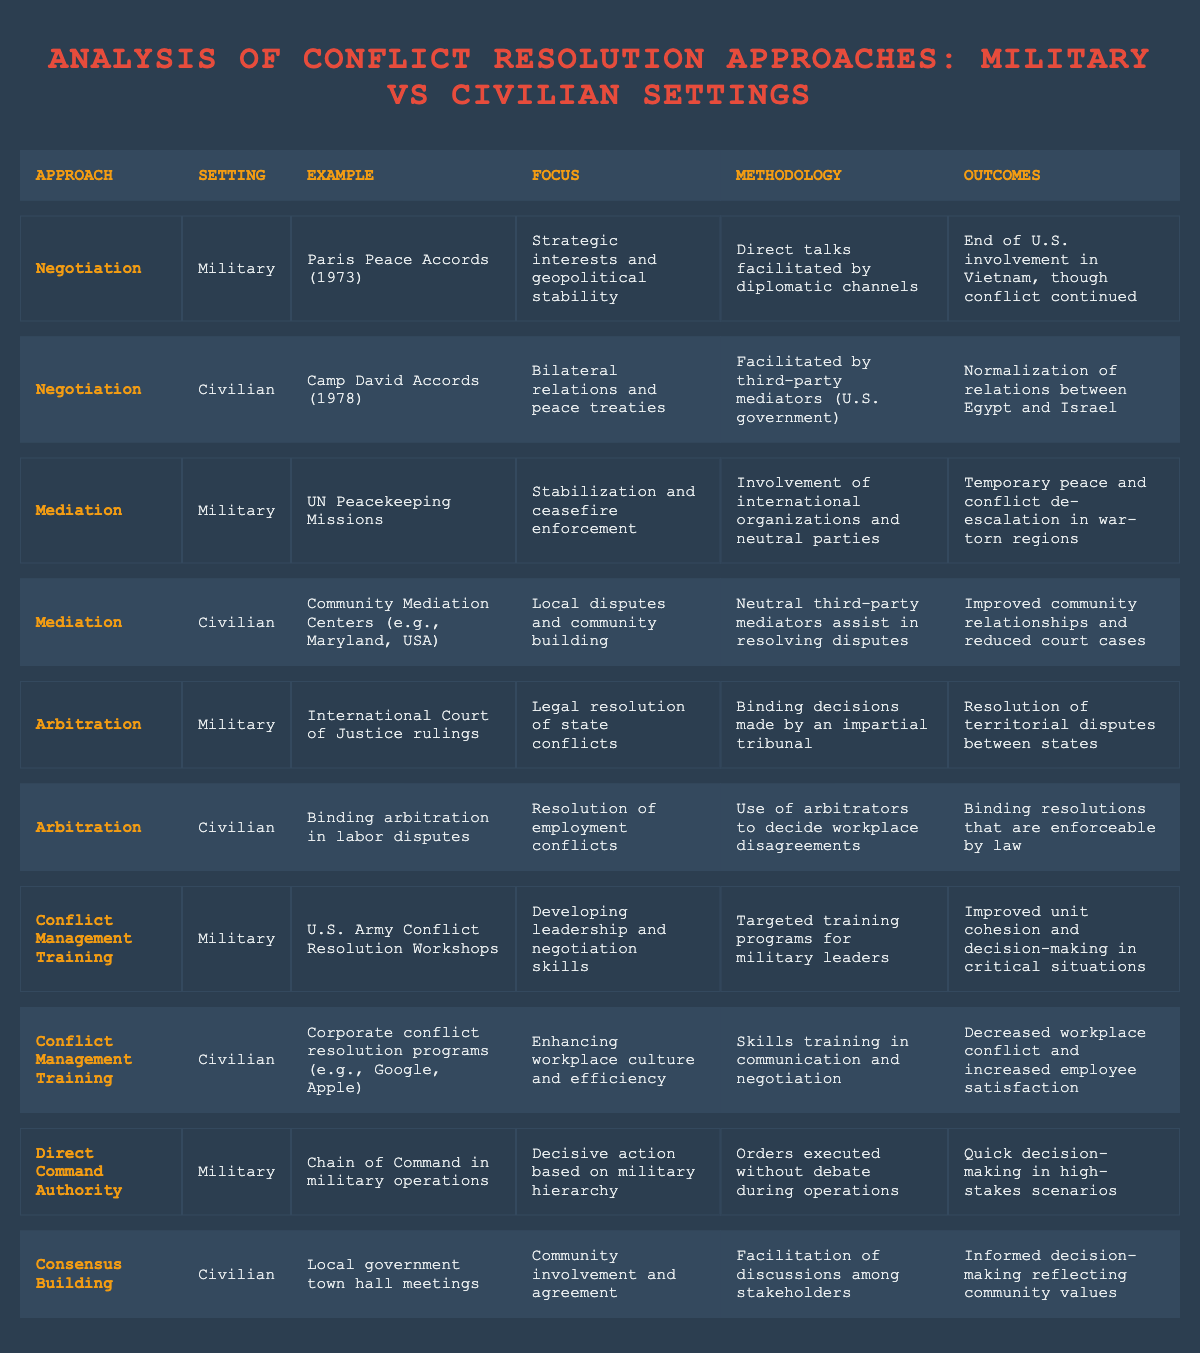What are the two conflict resolution approaches used in military settings? The table lists the conflict resolution approaches used in military settings. They are Negotiation and Mediation.
Answer: Negotiation, Mediation Which approach utilizes third-party mediators in civilian settings? The table indicates that the Negotiation approach in civilian settings uses third-party mediators, specifically in the Camp David Accords example.
Answer: Negotiation How many military approaches focus on stabilization and ceasefire enforcement? The table provides one specific approach, which is Mediation, noted for focusing on stabilization and ceasefire enforcement through UN Peacekeeping Missions.
Answer: 1 What was the outcome of the Paris Peace Accords? From the table, the outcome of the Paris Peace Accords is the end of U.S. involvement in Vietnam, though conflict continued.
Answer: End of U.S. involvement in Vietnam, conflict continued What is the difference in focus between military and civilian approaches to negotiation? The military approach focuses on strategic interests and geopolitical stability, while the civilian approach emphasizes bilateral relations and peace treaties.
Answer: Strategic interests (military) vs. bilateral relations (civilian) Which two approaches are associated with binding decisions? The table shows that Arbitration is associated with binding decisions in both military (International Court of Justice rulings) and civilian (labor disputes) settings.
Answer: Arbitration What outcomes are reported for conflict management training in military versus civilian settings? The military conflict management training leads to improved unit cohesion and decision-making, while in civilian settings, it results in decreased workplace conflict and increased employee satisfaction.
Answer: Improved unit cohesion (military) vs. decreased workplace conflict (civilian) Which military approach allows for quick decision-making, and how is it implemented? The Direct Command Authority approach allows for quick decision-making by executing orders without debate during operations based on military hierarchy.
Answer: Direct Command Authority, orders executed without debate Are community mediation centers a military or civilian approach? According to the table, community mediation centers serve as a civilian approach to conflict resolution focused on local disputes and community building.
Answer: Civilian How does the methodology of mediation differ between military and civilian settings? In military settings, mediation involves international organizations and neutral parties, while in civilian settings, it involves neutral third-party mediators assisting in resolving disputes.
Answer: Different organizations (military vs. civilian) 